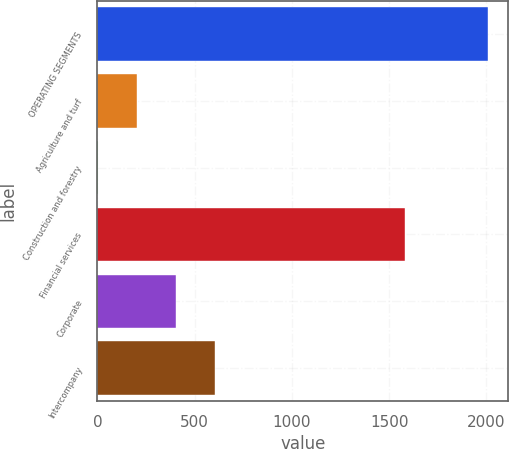Convert chart. <chart><loc_0><loc_0><loc_500><loc_500><bar_chart><fcel>OPERATING SEGMENTS<fcel>Agriculture and turf<fcel>Construction and forestry<fcel>Financial services<fcel>Corporate<fcel>Intercompany<nl><fcel>2011<fcel>203.8<fcel>3<fcel>1581<fcel>404.6<fcel>605.4<nl></chart> 